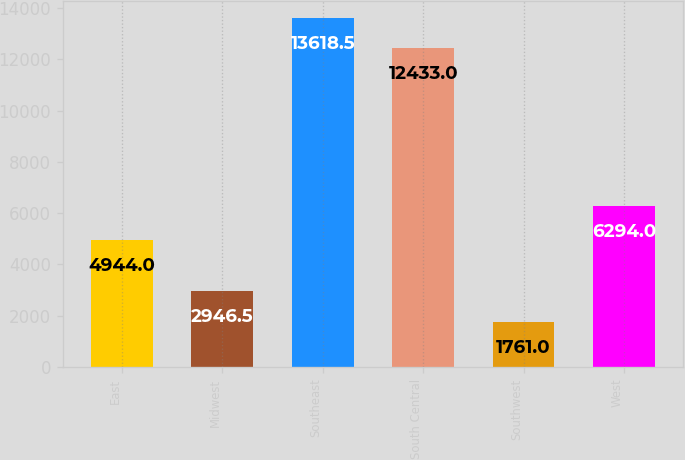Convert chart. <chart><loc_0><loc_0><loc_500><loc_500><bar_chart><fcel>East<fcel>Midwest<fcel>Southeast<fcel>South Central<fcel>Southwest<fcel>West<nl><fcel>4944<fcel>2946.5<fcel>13618.5<fcel>12433<fcel>1761<fcel>6294<nl></chart> 